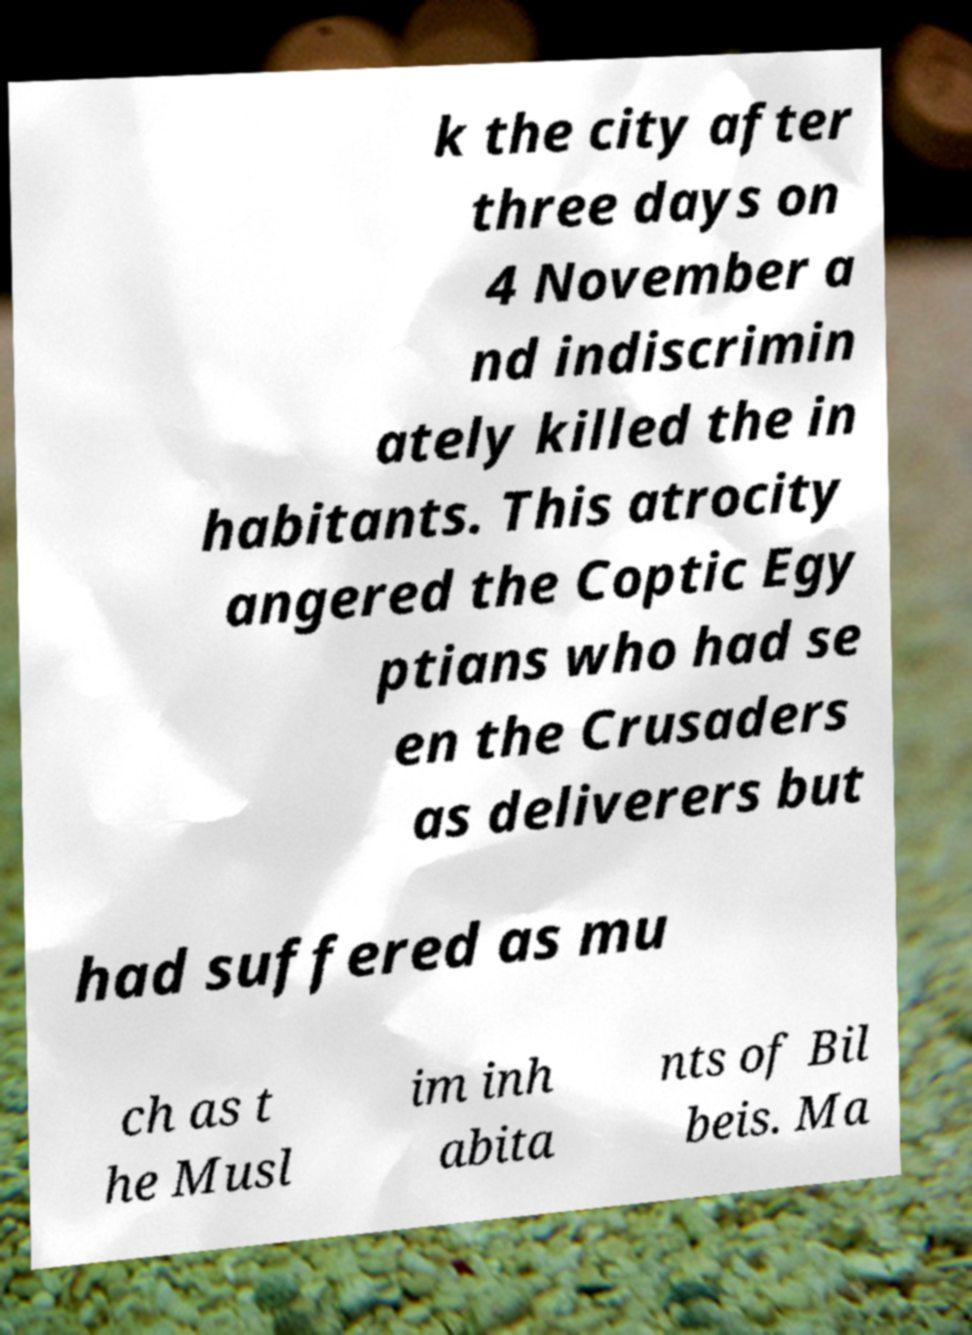Can you read and provide the text displayed in the image?This photo seems to have some interesting text. Can you extract and type it out for me? k the city after three days on 4 November a nd indiscrimin ately killed the in habitants. This atrocity angered the Coptic Egy ptians who had se en the Crusaders as deliverers but had suffered as mu ch as t he Musl im inh abita nts of Bil beis. Ma 